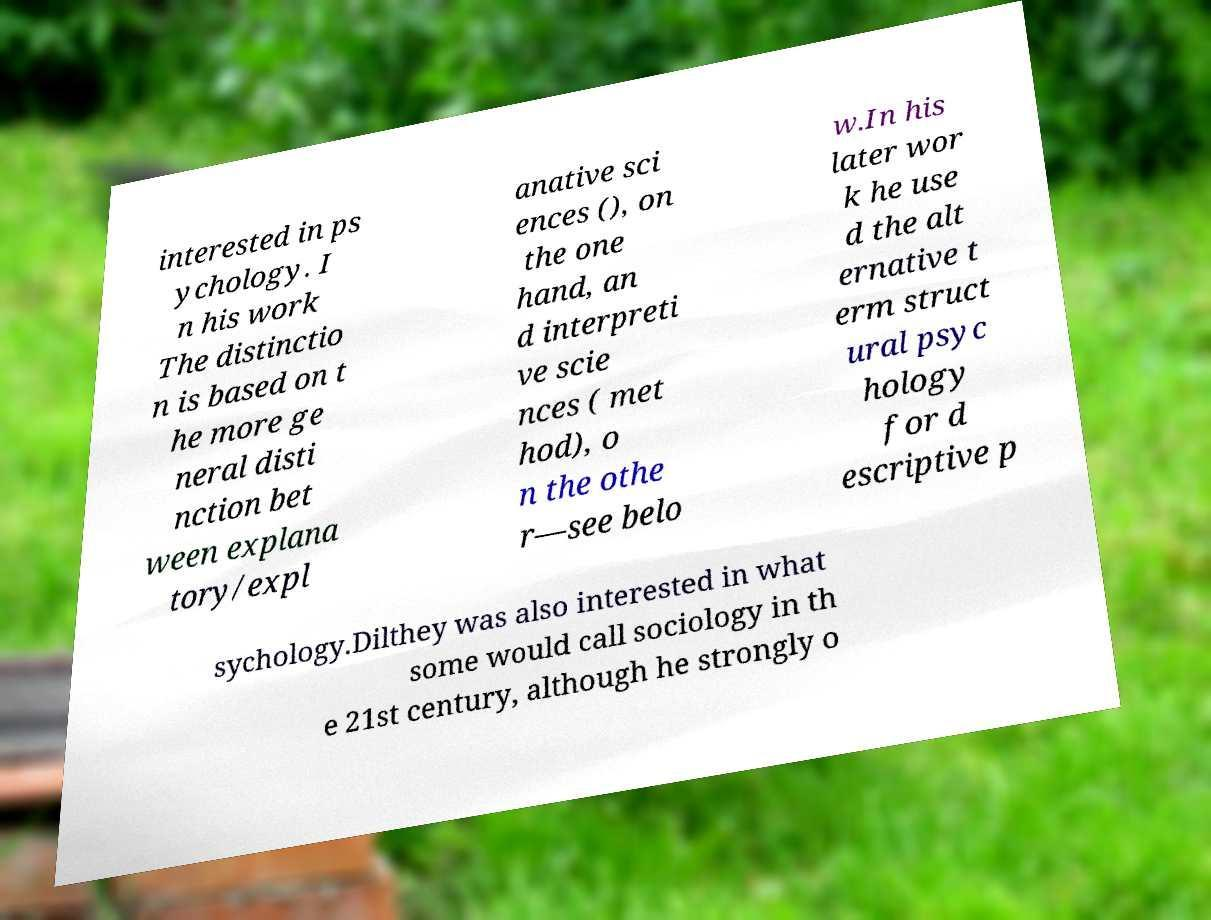I need the written content from this picture converted into text. Can you do that? interested in ps ychology. I n his work The distinctio n is based on t he more ge neral disti nction bet ween explana tory/expl anative sci ences (), on the one hand, an d interpreti ve scie nces ( met hod), o n the othe r—see belo w.In his later wor k he use d the alt ernative t erm struct ural psyc hology for d escriptive p sychology.Dilthey was also interested in what some would call sociology in th e 21st century, although he strongly o 